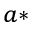<formula> <loc_0><loc_0><loc_500><loc_500>^ { a * }</formula> 